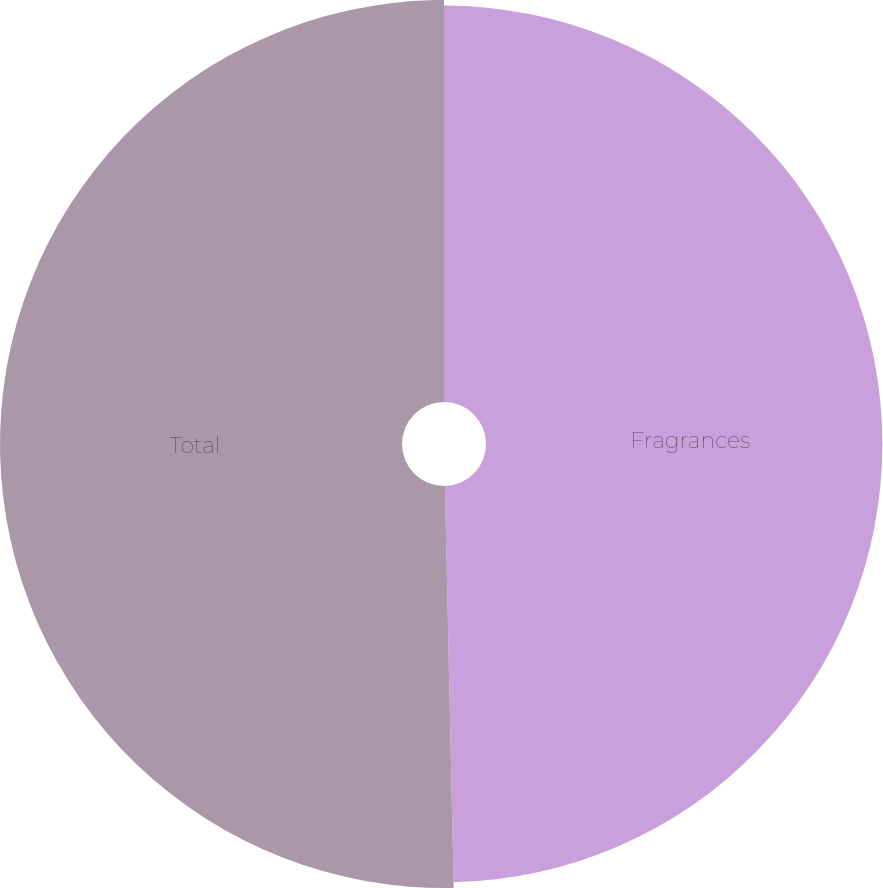<chart> <loc_0><loc_0><loc_500><loc_500><pie_chart><fcel>Fragrances<fcel>Total<nl><fcel>49.65%<fcel>50.35%<nl></chart> 